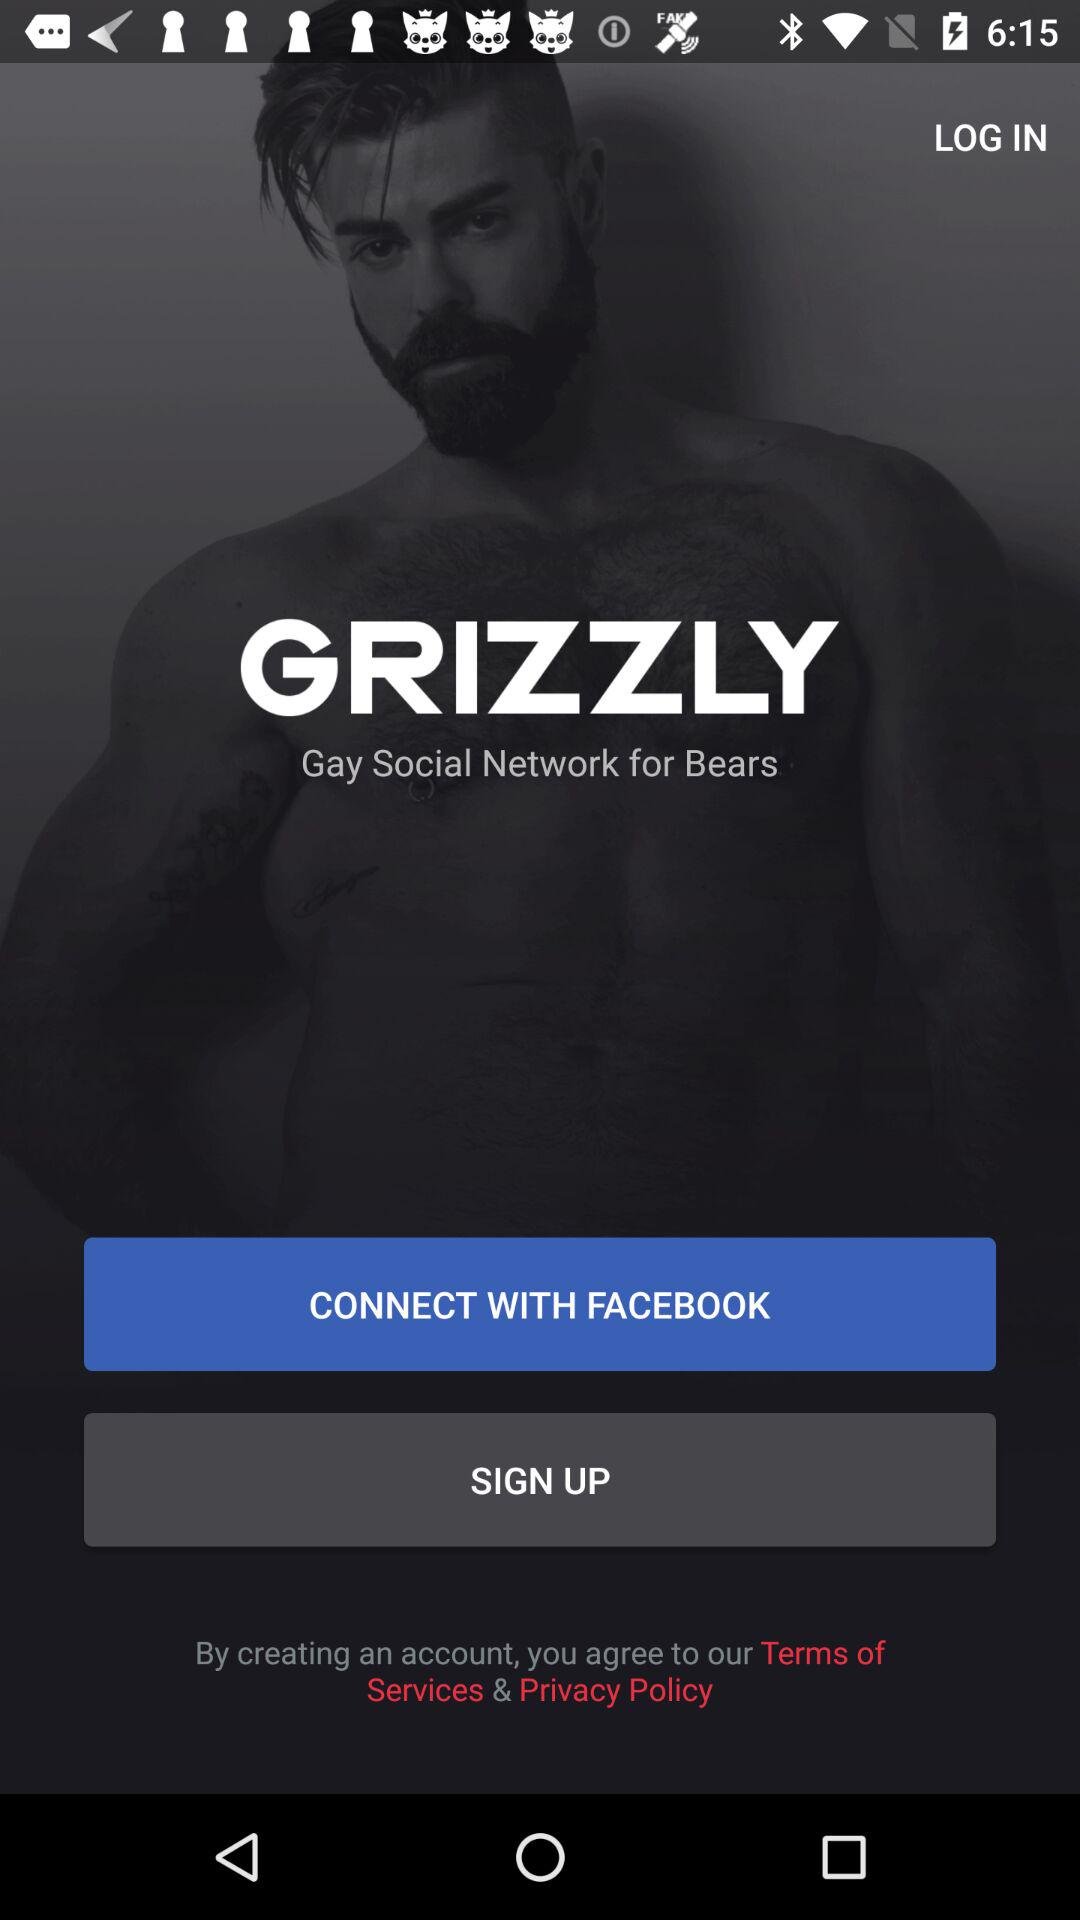What account can I use to sign in? The account that you use to sign in is "FACEBOOK". 